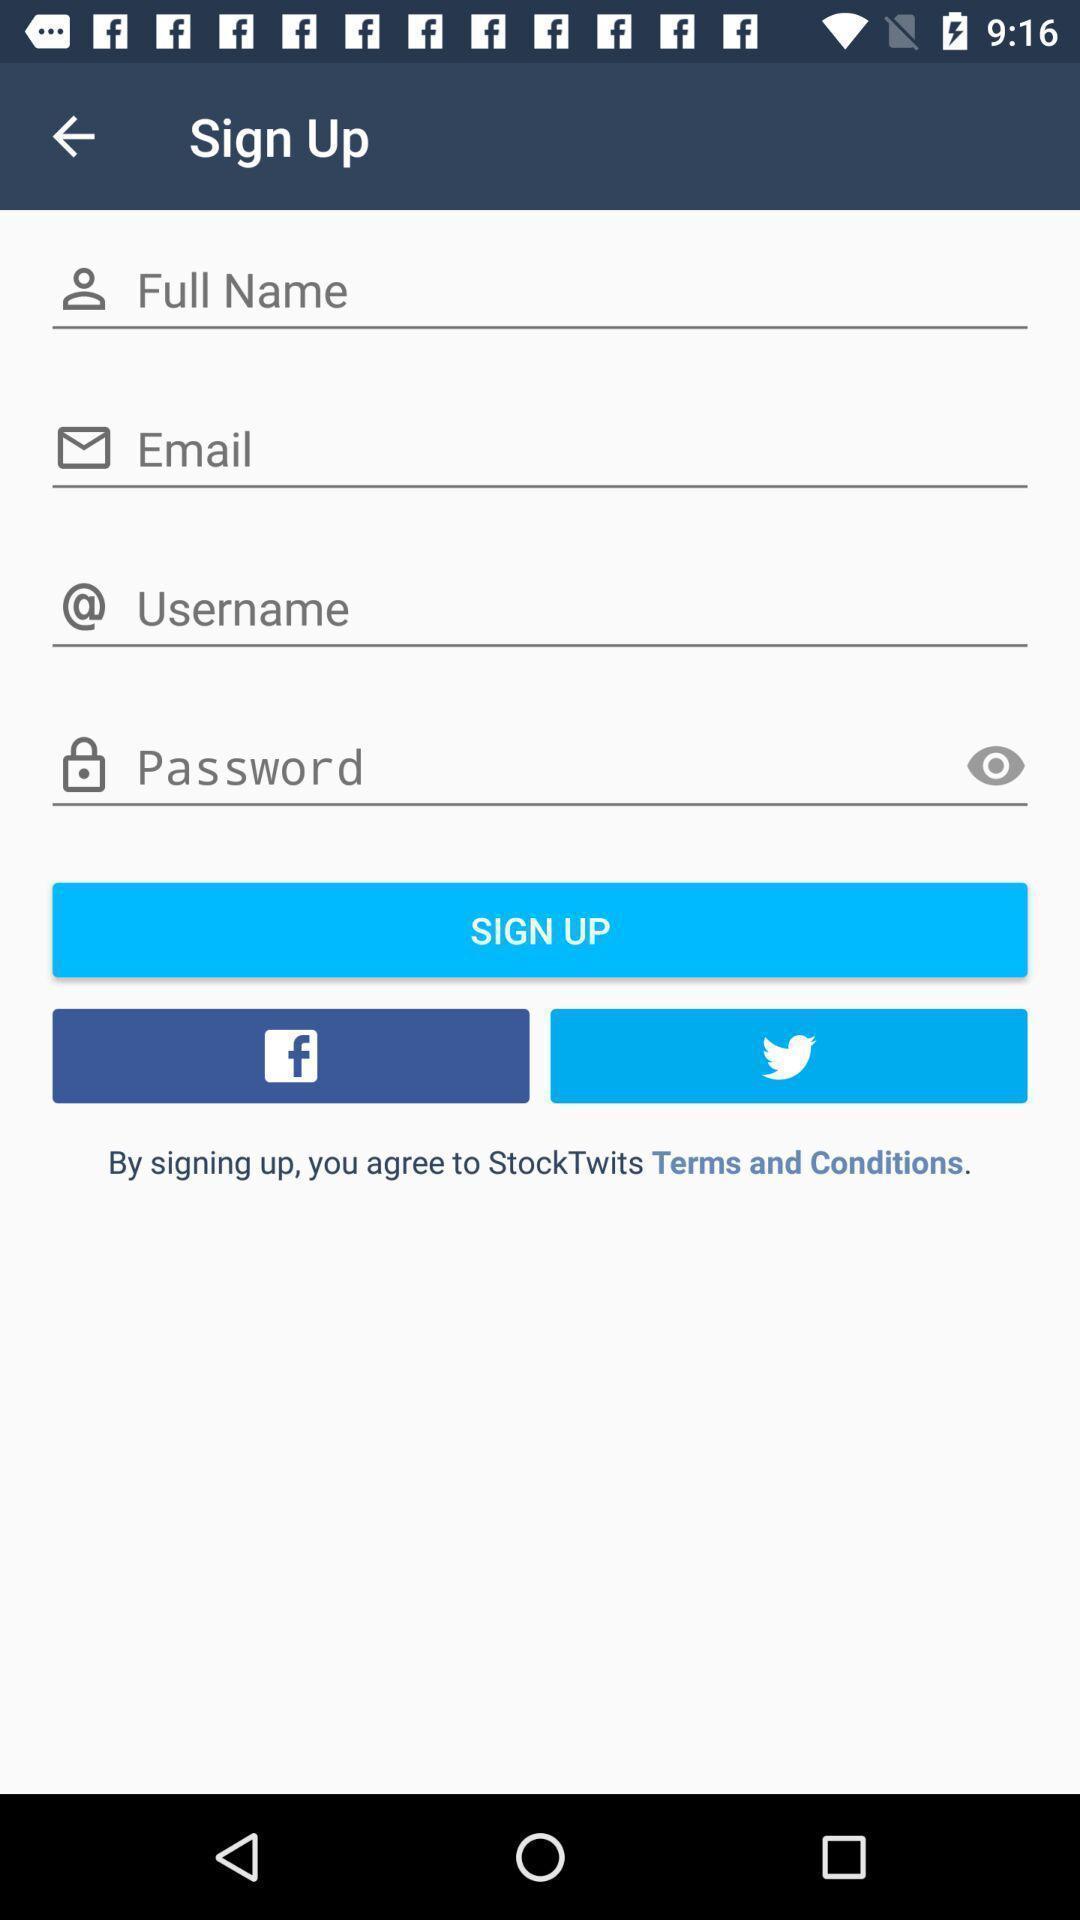What is the overall content of this screenshot? Sign up page. 